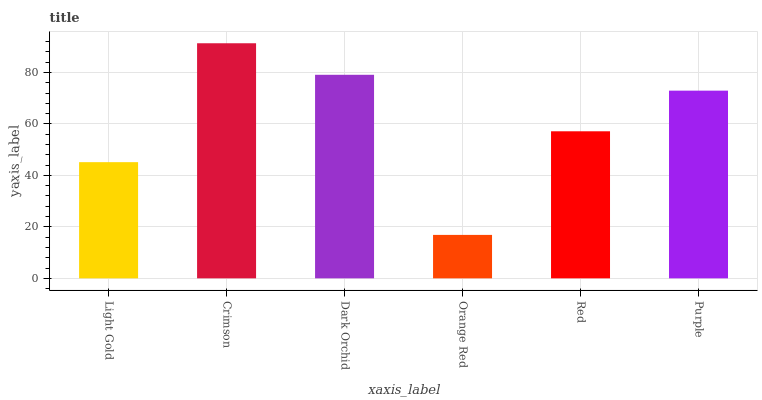Is Dark Orchid the minimum?
Answer yes or no. No. Is Dark Orchid the maximum?
Answer yes or no. No. Is Crimson greater than Dark Orchid?
Answer yes or no. Yes. Is Dark Orchid less than Crimson?
Answer yes or no. Yes. Is Dark Orchid greater than Crimson?
Answer yes or no. No. Is Crimson less than Dark Orchid?
Answer yes or no. No. Is Purple the high median?
Answer yes or no. Yes. Is Red the low median?
Answer yes or no. Yes. Is Dark Orchid the high median?
Answer yes or no. No. Is Light Gold the low median?
Answer yes or no. No. 